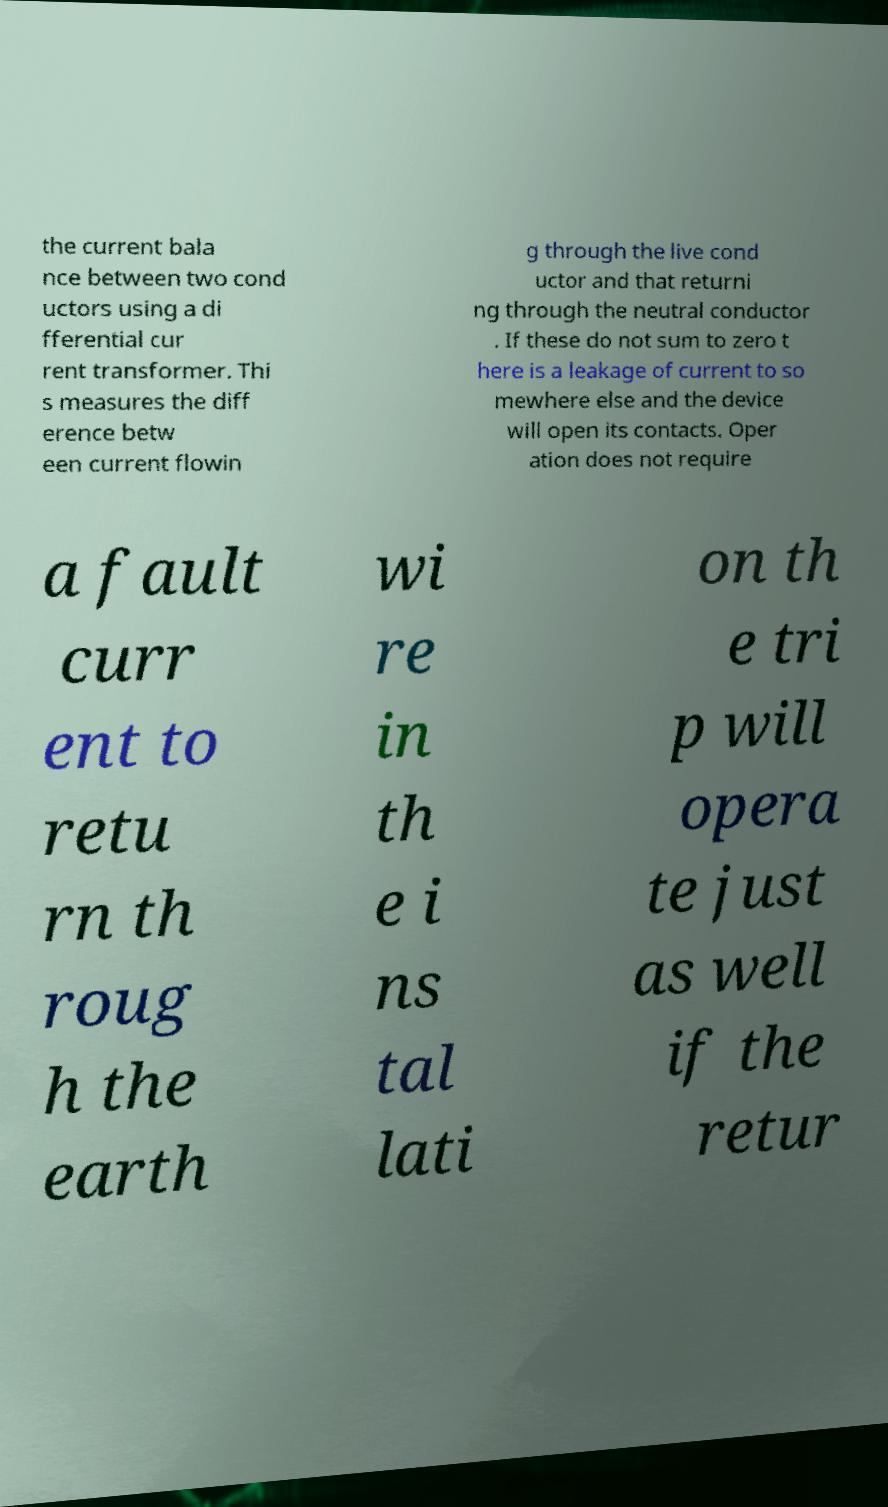Can you read and provide the text displayed in the image?This photo seems to have some interesting text. Can you extract and type it out for me? the current bala nce between two cond uctors using a di fferential cur rent transformer. Thi s measures the diff erence betw een current flowin g through the live cond uctor and that returni ng through the neutral conductor . If these do not sum to zero t here is a leakage of current to so mewhere else and the device will open its contacts. Oper ation does not require a fault curr ent to retu rn th roug h the earth wi re in th e i ns tal lati on th e tri p will opera te just as well if the retur 